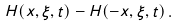Convert formula to latex. <formula><loc_0><loc_0><loc_500><loc_500>H ( x , \xi , t ) - H ( - x , \xi , t ) \, .</formula> 